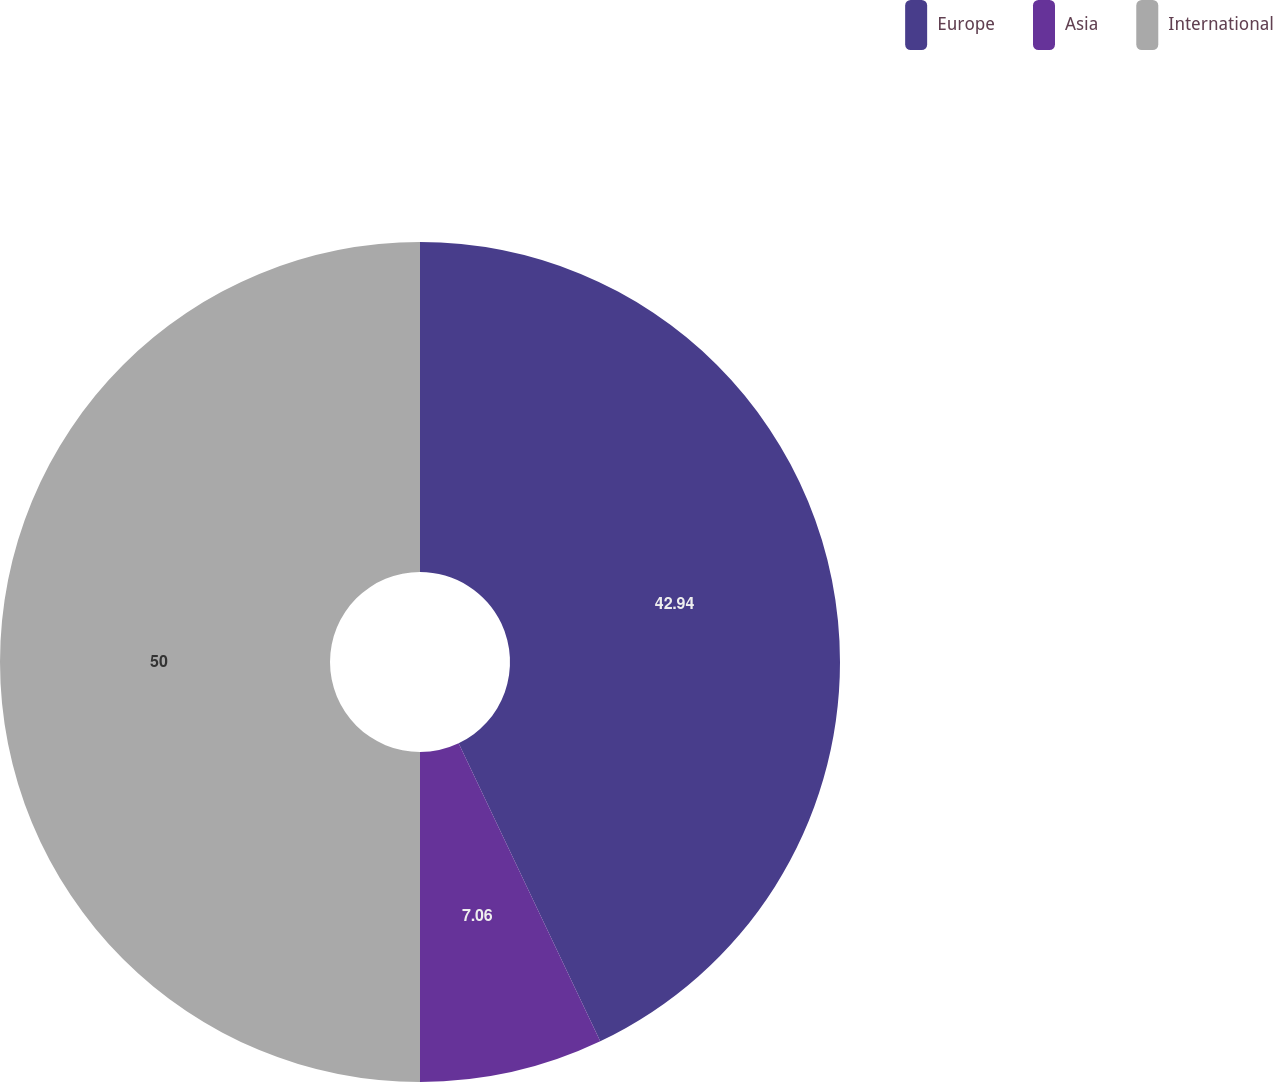Convert chart. <chart><loc_0><loc_0><loc_500><loc_500><pie_chart><fcel>Europe<fcel>Asia<fcel>International<nl><fcel>42.94%<fcel>7.06%<fcel>50.0%<nl></chart> 